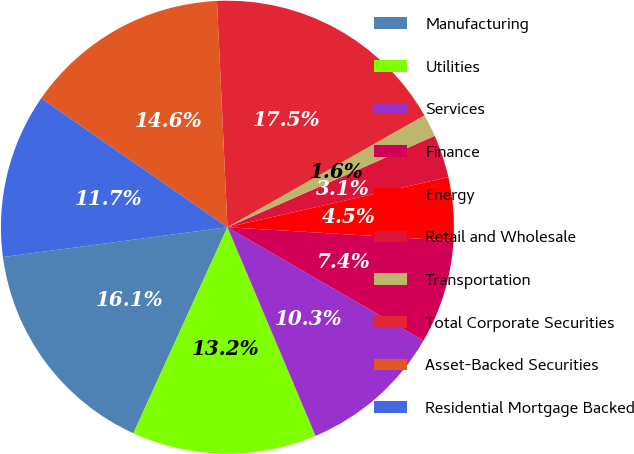Convert chart. <chart><loc_0><loc_0><loc_500><loc_500><pie_chart><fcel>Manufacturing<fcel>Utilities<fcel>Services<fcel>Finance<fcel>Energy<fcel>Retail and Wholesale<fcel>Transportation<fcel>Total Corporate Securities<fcel>Asset-Backed Securities<fcel>Residential Mortgage Backed<nl><fcel>16.08%<fcel>13.18%<fcel>10.29%<fcel>7.4%<fcel>4.5%<fcel>3.06%<fcel>1.61%<fcel>17.52%<fcel>14.63%<fcel>11.74%<nl></chart> 